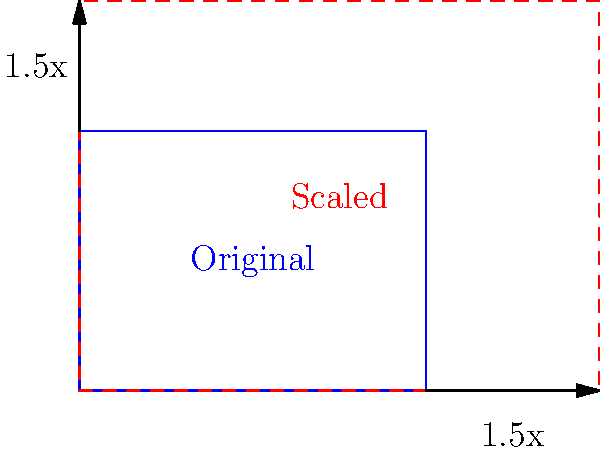A website header with dimensions 400x300 pixels needs to be scaled up to improve visibility on larger screens. If the width is increased to 600 pixels while maintaining the aspect ratio, what will be the new height of the header? How might this scaling affect user engagement, considering the principles of responsive design? To solve this problem and understand its impact on user engagement, let's follow these steps:

1. Identify the scaling factor:
   New width / Original width = Scaling factor
   $600 / 400 = 1.5$

2. Apply the scaling factor to the height:
   New height = Original height × Scaling factor
   $300 \times 1.5 = 450$ pixels

3. Verify the aspect ratio:
   Original aspect ratio: $400:300 = 4:3$
   New aspect ratio: $600:450 = 4:3$

4. Impact on user engagement:
   a) Improved visibility: The larger header may enhance readability and visual impact, potentially increasing user engagement.
   b) Responsive design: The proportional scaling maintains the design integrity across different screen sizes, ensuring a consistent user experience.
   c) Above-the-fold content: The increased header size may push more content below the fold, potentially affecting initial user engagement with key information.
   d) Load time: Larger images may increase load time, which could negatively impact user experience and engagement, especially on slower connections.
   e) Mobile considerations: While beneficial for larger screens, this scaling might need to be adjusted for mobile devices to prevent the header from dominating the viewport.
Answer: 450 pixels; increased visibility but potential trade-offs in above-fold content and load time. 